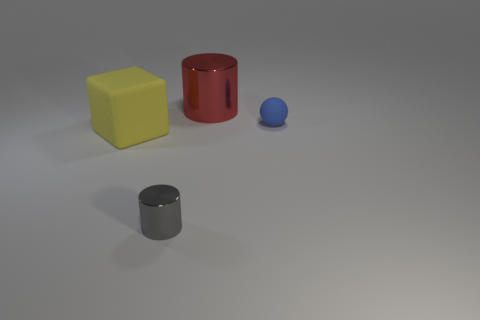Subtract 1 spheres. How many spheres are left? 0 Add 2 small purple rubber blocks. How many objects exist? 6 Subtract all red cylinders. How many cylinders are left? 1 Subtract all green cylinders. Subtract all yellow cubes. How many cylinders are left? 2 Subtract all cyan spheres. How many red cylinders are left? 1 Subtract 0 gray balls. How many objects are left? 4 Subtract all balls. How many objects are left? 3 Subtract all big red things. Subtract all big blocks. How many objects are left? 2 Add 1 shiny cylinders. How many shiny cylinders are left? 3 Add 4 yellow things. How many yellow things exist? 5 